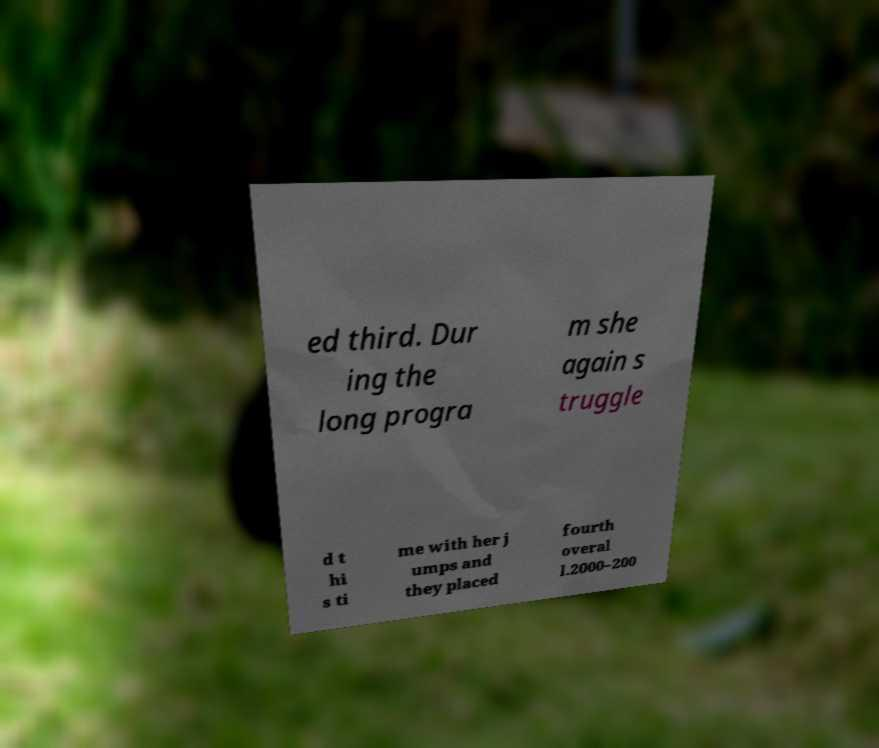What messages or text are displayed in this image? I need them in a readable, typed format. ed third. Dur ing the long progra m she again s truggle d t hi s ti me with her j umps and they placed fourth overal l.2000–200 